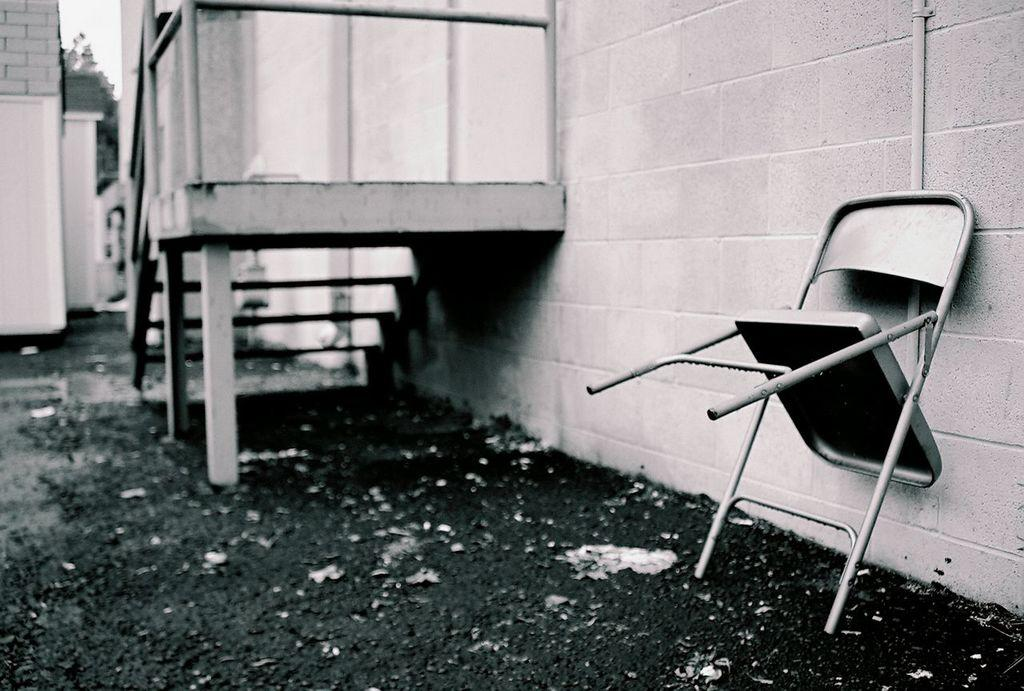What type of structure can be seen in the image? There is a building in the image. What architectural feature is present in the image? There are stairs in the image. What other object can be seen in the image? There is a pipe in the image. What type of furniture is present in the image? There is a chair in the image. What type of wall is visible in the image? There is a brick wall in the image. What is the price of the fish in the image? There is no fish present in the image, so it is not possible to determine the price of any fish. 